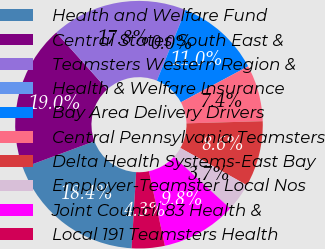<chart> <loc_0><loc_0><loc_500><loc_500><pie_chart><fcel>Health and Welfare Fund<fcel>Central States South East &<fcel>Teamsters Western Region &<fcel>Health & Welfare Insurance<fcel>Bay Area Delivery Drivers<fcel>Central Pennsylvania Teamsters<fcel>Delta Health Systems-East Bay<fcel>Employer-Teamster Local Nos<fcel>Joint Council 83 Health &<fcel>Local 191 Teamsters Health<nl><fcel>18.4%<fcel>19.01%<fcel>17.78%<fcel>0.01%<fcel>11.04%<fcel>7.36%<fcel>8.59%<fcel>3.69%<fcel>9.82%<fcel>4.3%<nl></chart> 